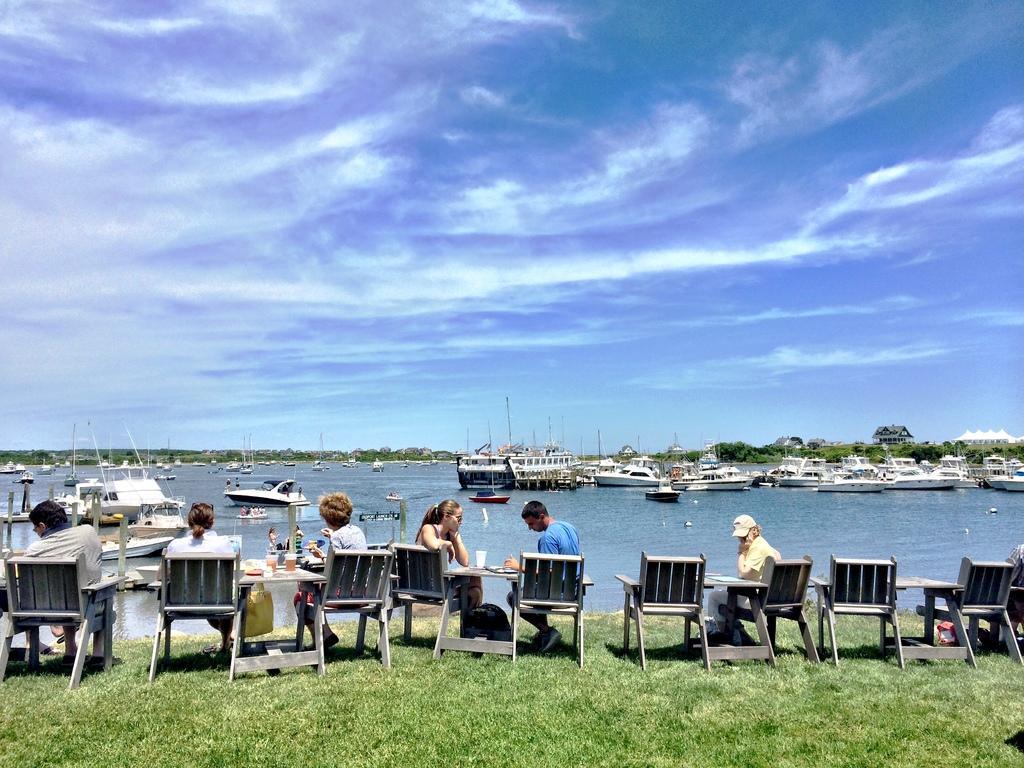How would you summarize this image in a sentence or two? The image consists of many men sat on chair around table in front of sea, there are many ships in the sea and sky is filled with clouds. 